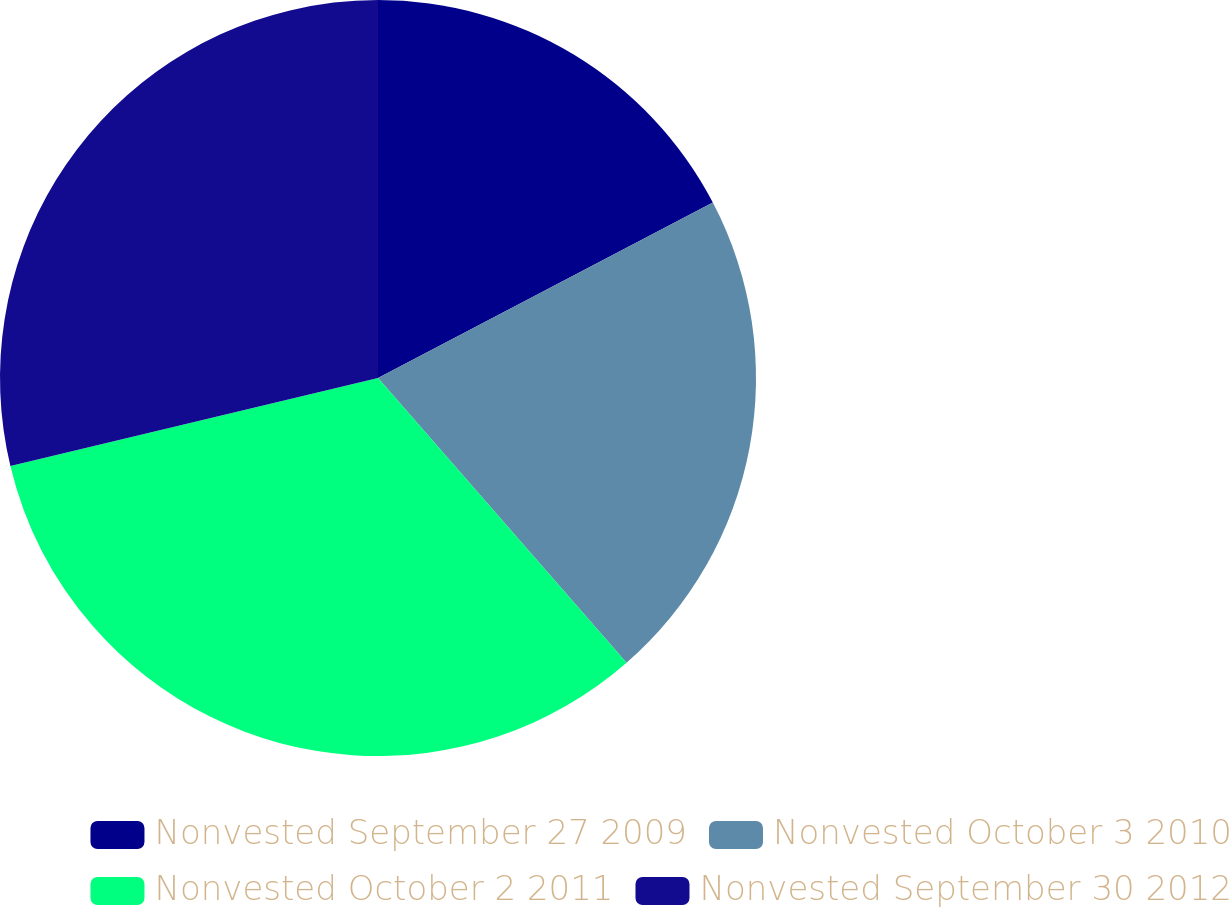<chart> <loc_0><loc_0><loc_500><loc_500><pie_chart><fcel>Nonvested September 27 2009<fcel>Nonvested October 3 2010<fcel>Nonvested October 2 2011<fcel>Nonvested September 30 2012<nl><fcel>17.32%<fcel>21.26%<fcel>32.68%<fcel>28.74%<nl></chart> 